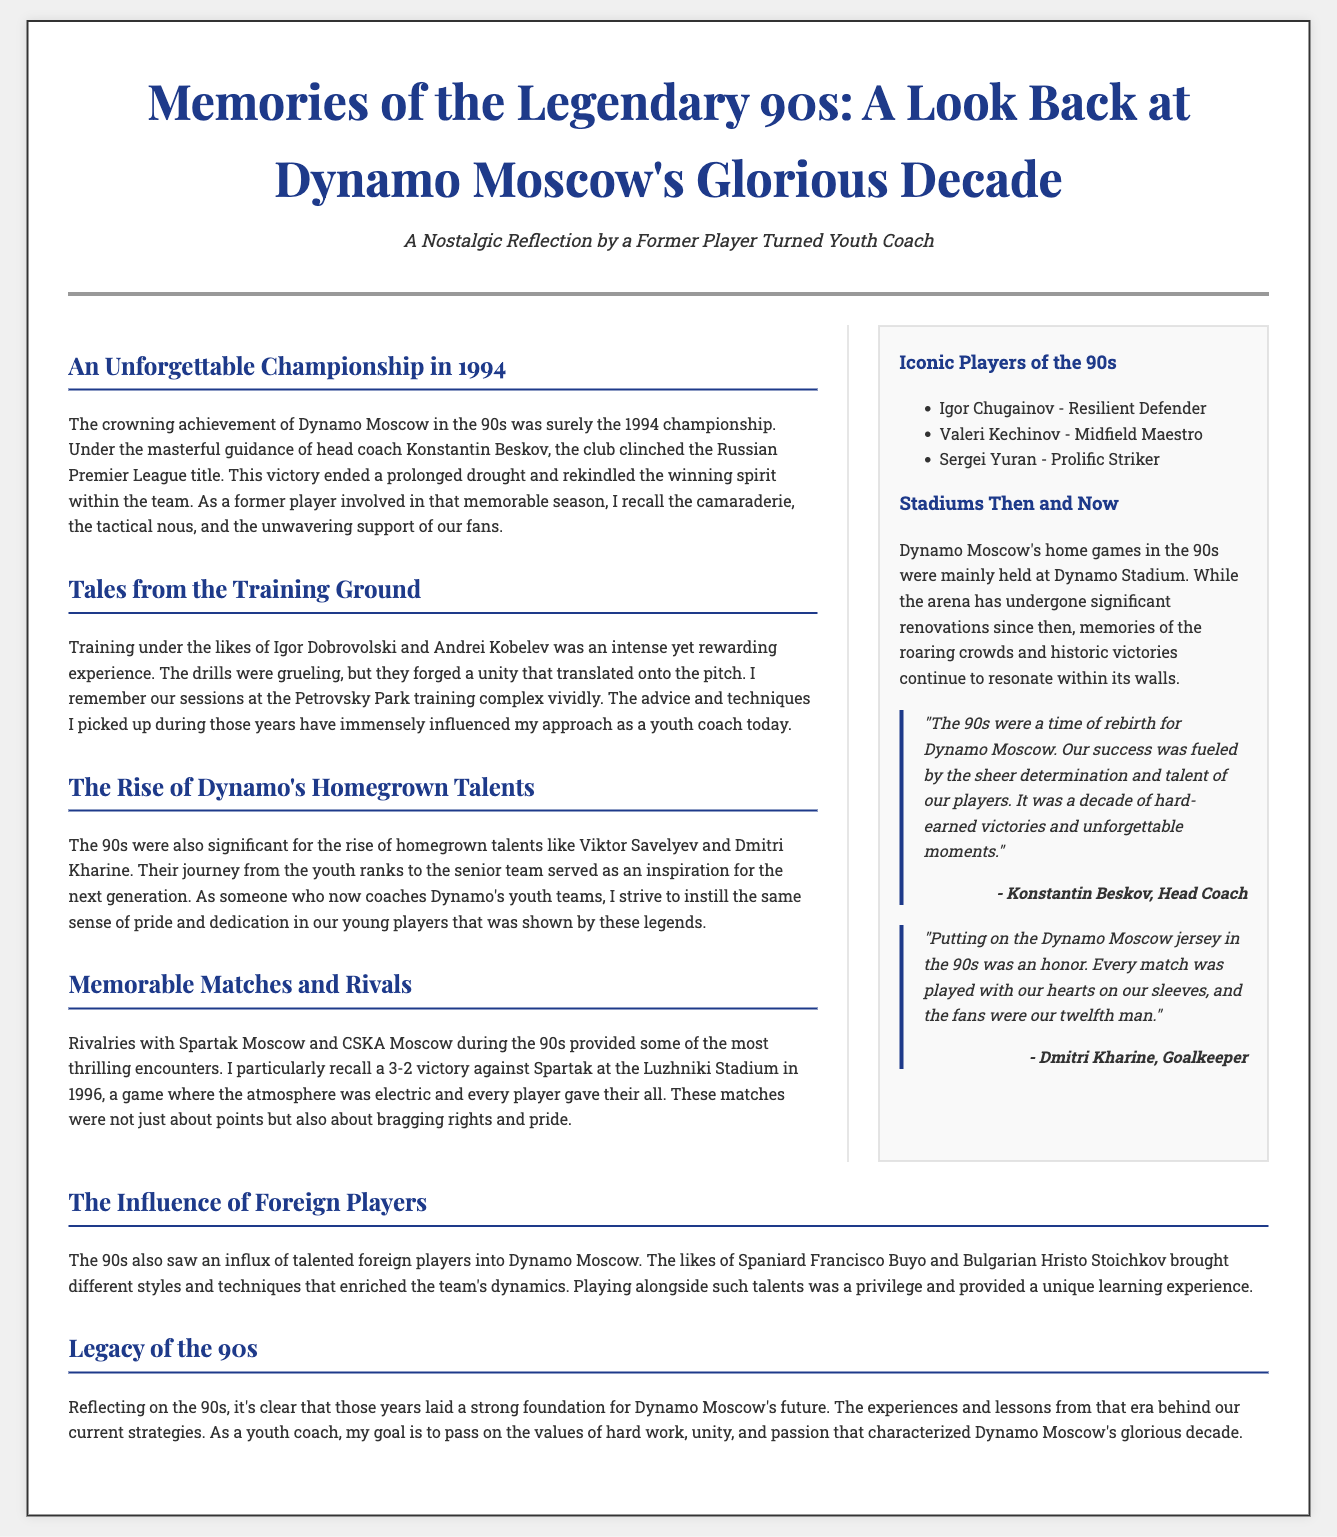What year did Dynamo Moscow win the championship? The document states that Dynamo Moscow won the championship in 1994.
Answer: 1994 Who was the head coach during the 1994 championship? The head coach during the 1994 championship was Konstantin Beskov.
Answer: Konstantin Beskov Which player was mentioned as a resilient defender? The document lists Igor Chugainov as a resilient defender.
Answer: Igor Chugainov What was significant about the training sessions at Petrovsky Park? The training sessions at Petrovsky Park forged unity that translated onto the pitch.
Answer: Forged unity What was the atmosphere like during the 3-2 victory against Spartak? The atmosphere during the victory against Spartak was described as electric.
Answer: Electric Which foreign player brought a different style to Dynamo Moscow? Francisco Buyo is mentioned as a talented foreign player who brought a different style.
Answer: Francisco Buyo What are some values that the youth coach wants to pass on? The youth coach wants to pass on values of hard work, unity, and passion.
Answer: Hard work, unity, and passion In which stadium did Dynamo Moscow play their home games in the 90s? Dynamo Moscow's home games in the 90s were mainly held at Dynamo Stadium.
Answer: Dynamo Stadium 